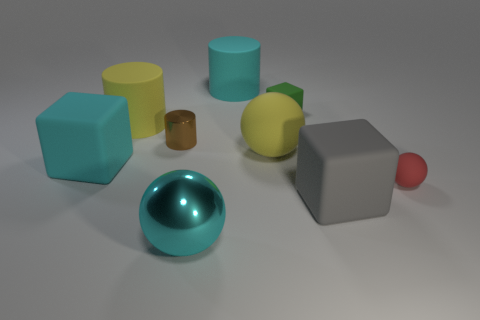Is there any other thing that is the same color as the small cube?
Keep it short and to the point. No. What shape is the yellow rubber thing behind the shiny object that is behind the big yellow thing right of the cyan metal ball?
Ensure brevity in your answer.  Cylinder. Do the metal thing that is behind the small red rubber sphere and the sphere to the right of the tiny green cube have the same size?
Provide a succinct answer. Yes. What number of gray things have the same material as the brown object?
Your answer should be compact. 0. There is a metallic object in front of the big rubber object in front of the cyan cube; how many things are right of it?
Your answer should be compact. 5. Does the red object have the same shape as the cyan metallic thing?
Offer a terse response. Yes. Is there a big gray thing of the same shape as the small green rubber thing?
Your answer should be very brief. Yes. The red object that is the same size as the brown metal thing is what shape?
Provide a succinct answer. Sphere. What material is the big cyan object that is in front of the large block in front of the matte object that is right of the gray cube made of?
Your answer should be compact. Metal. Is the gray object the same size as the red thing?
Your answer should be compact. No. 